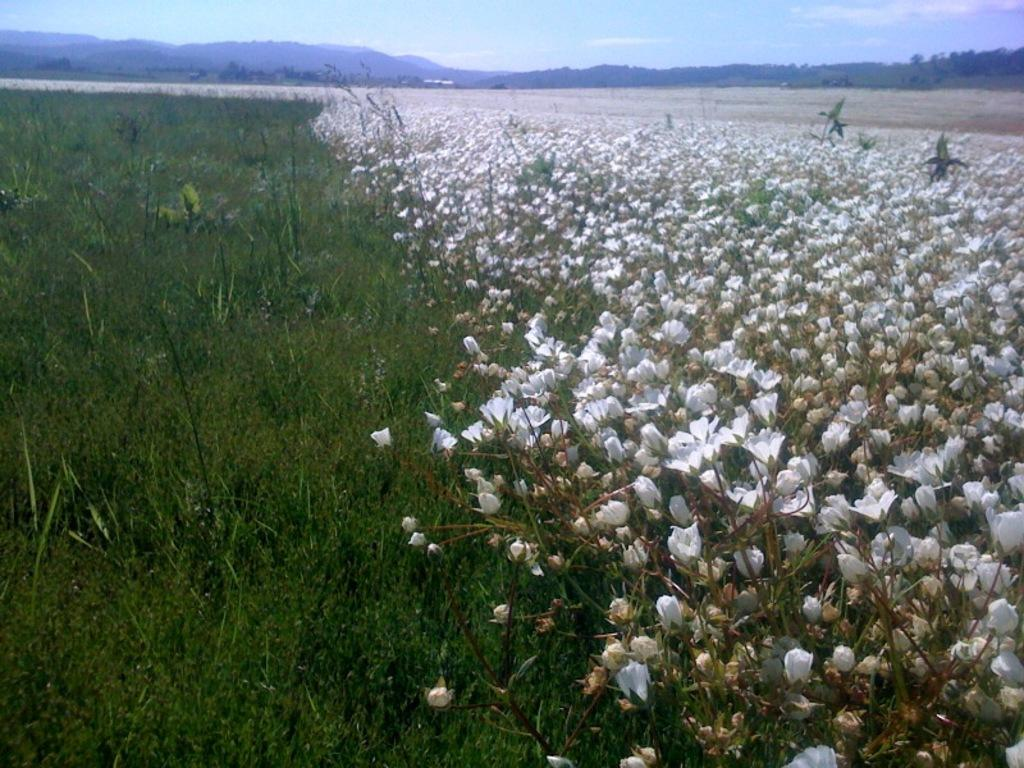What type of plants can be seen in the image? There are flowers in the image. What color are the flowers? The flowers are white in color. What type of vegetation is visible in the image besides the flowers? There is grass visible in the image. What type of landscape feature can be seen in the image? There are hills in the image. What part of the natural environment is visible in the image? The sky is visible in the image. Can you tell me how many times the flowers have been copied in the image? There is no indication in the image that the flowers have been copied, and therefore this question cannot be answered. 